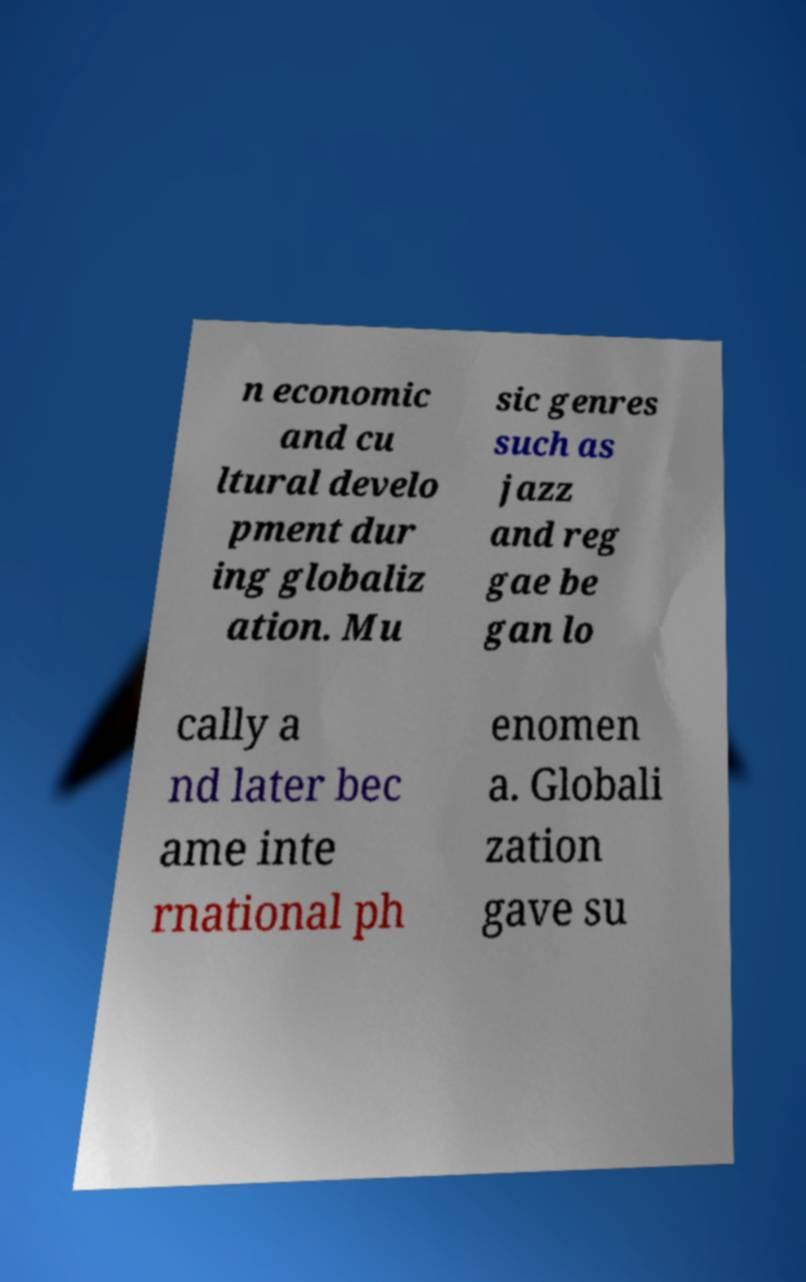Could you extract and type out the text from this image? n economic and cu ltural develo pment dur ing globaliz ation. Mu sic genres such as jazz and reg gae be gan lo cally a nd later bec ame inte rnational ph enomen a. Globali zation gave su 